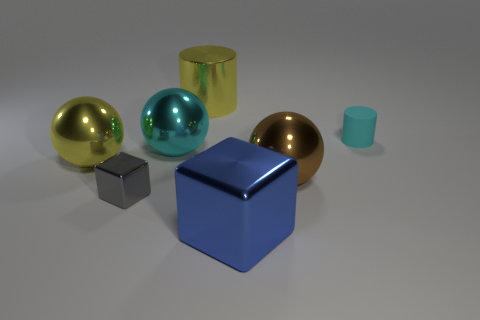What is the shape of the large object that is the same color as the tiny cylinder?
Offer a terse response. Sphere. There is a ball that is to the left of the cyan sphere; is it the same color as the shiny block in front of the small gray metal object?
Offer a terse response. No. What color is the other object that is the same size as the matte thing?
Your answer should be very brief. Gray. Is there a cylinder that has the same color as the large cube?
Offer a very short reply. No. Does the shiny object behind the cyan rubber thing have the same size as the brown metal ball?
Provide a short and direct response. Yes. Is the number of blue shiny cubes behind the big brown metal ball the same as the number of blue rubber objects?
Your answer should be compact. Yes. How many things are yellow metal things in front of the big cyan metallic ball or big cyan metal objects?
Make the answer very short. 2. The thing that is both on the right side of the large blue cube and on the left side of the tiny cylinder has what shape?
Your response must be concise. Sphere. How many things are big things that are behind the small cylinder or large yellow shiny spheres on the left side of the small cyan matte object?
Make the answer very short. 2. How many other things are there of the same size as the blue block?
Your answer should be very brief. 4. 